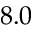Convert formula to latex. <formula><loc_0><loc_0><loc_500><loc_500>8 . 0</formula> 